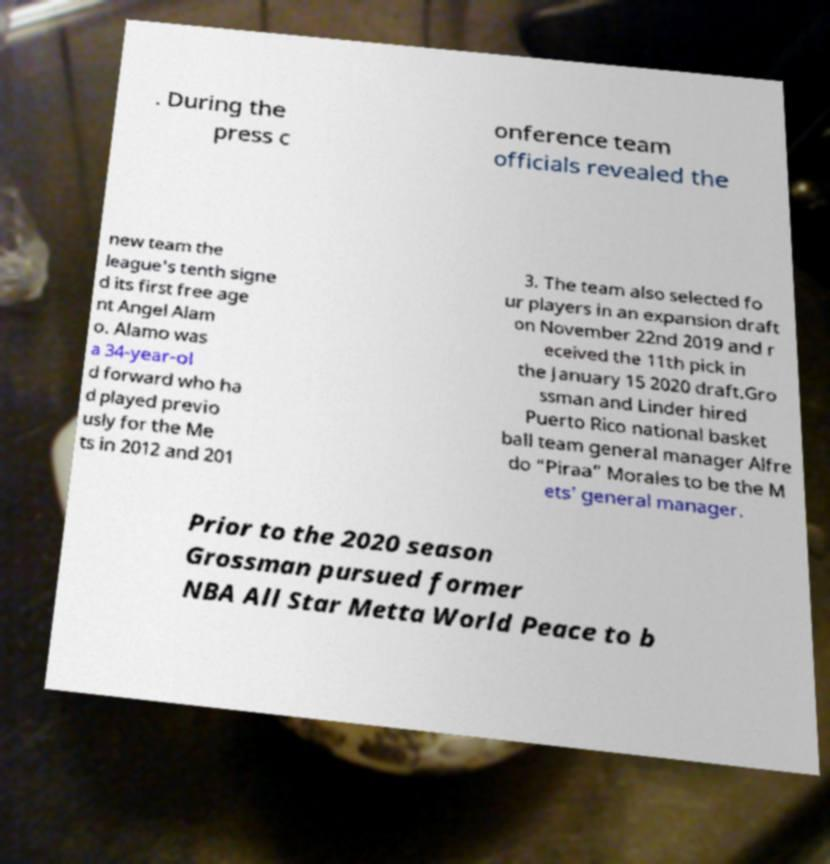Please read and relay the text visible in this image. What does it say? . During the press c onference team officials revealed the new team the league's tenth signe d its first free age nt Angel Alam o. Alamo was a 34-year-ol d forward who ha d played previo usly for the Me ts in 2012 and 201 3. The team also selected fo ur players in an expansion draft on November 22nd 2019 and r eceived the 11th pick in the January 15 2020 draft.Gro ssman and Linder hired Puerto Rico national basket ball team general manager Alfre do “Piraa” Morales to be the M ets' general manager. Prior to the 2020 season Grossman pursued former NBA All Star Metta World Peace to b 